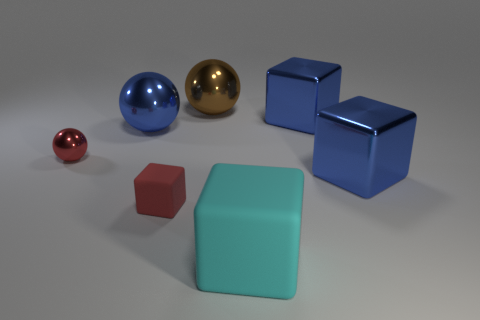Subtract all tiny red rubber blocks. How many blocks are left? 3 Subtract all green spheres. How many blue cubes are left? 2 Subtract all blue balls. How many balls are left? 2 Add 1 big blue blocks. How many objects exist? 8 Subtract all balls. How many objects are left? 4 Subtract 1 blocks. How many blocks are left? 3 Add 3 brown matte things. How many brown matte things exist? 3 Subtract 0 yellow balls. How many objects are left? 7 Subtract all yellow blocks. Subtract all purple spheres. How many blocks are left? 4 Subtract all blue shiny blocks. Subtract all red shiny objects. How many objects are left? 4 